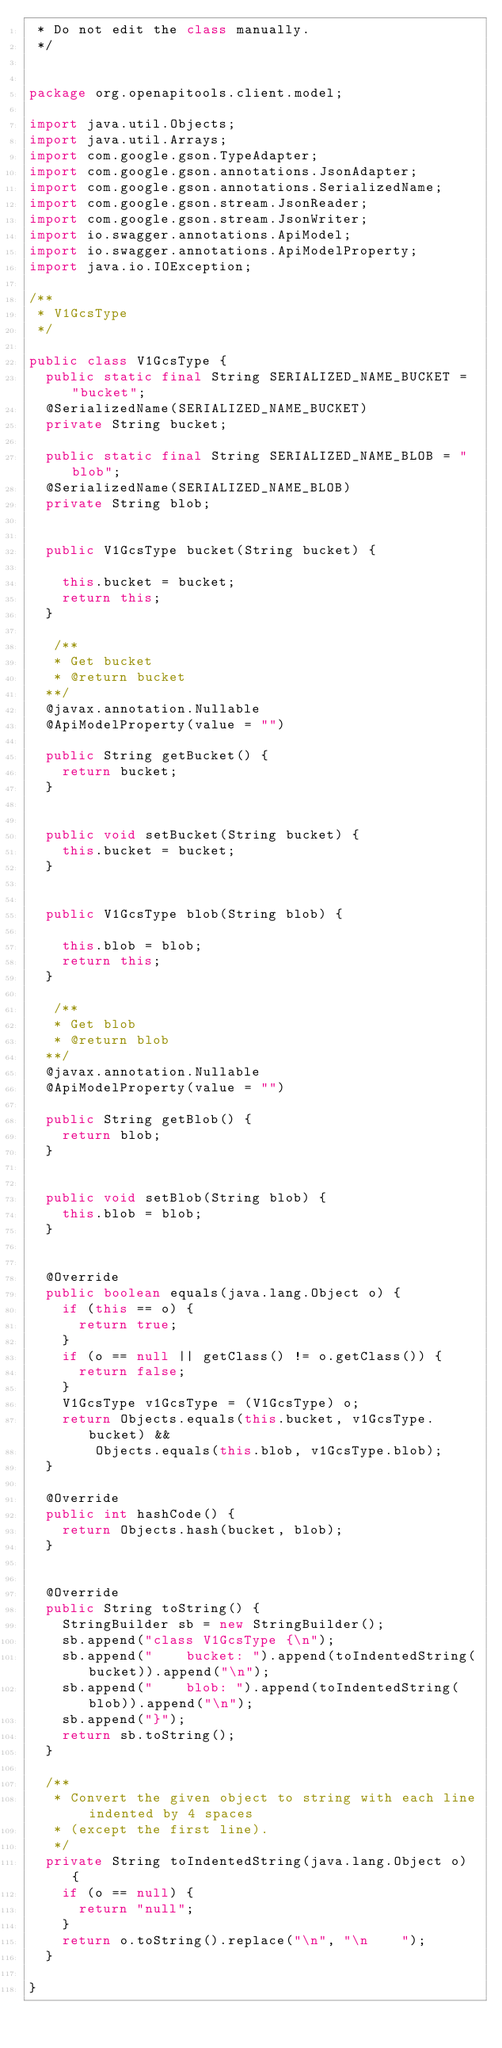Convert code to text. <code><loc_0><loc_0><loc_500><loc_500><_Java_> * Do not edit the class manually.
 */


package org.openapitools.client.model;

import java.util.Objects;
import java.util.Arrays;
import com.google.gson.TypeAdapter;
import com.google.gson.annotations.JsonAdapter;
import com.google.gson.annotations.SerializedName;
import com.google.gson.stream.JsonReader;
import com.google.gson.stream.JsonWriter;
import io.swagger.annotations.ApiModel;
import io.swagger.annotations.ApiModelProperty;
import java.io.IOException;

/**
 * V1GcsType
 */

public class V1GcsType {
  public static final String SERIALIZED_NAME_BUCKET = "bucket";
  @SerializedName(SERIALIZED_NAME_BUCKET)
  private String bucket;

  public static final String SERIALIZED_NAME_BLOB = "blob";
  @SerializedName(SERIALIZED_NAME_BLOB)
  private String blob;


  public V1GcsType bucket(String bucket) {
    
    this.bucket = bucket;
    return this;
  }

   /**
   * Get bucket
   * @return bucket
  **/
  @javax.annotation.Nullable
  @ApiModelProperty(value = "")

  public String getBucket() {
    return bucket;
  }


  public void setBucket(String bucket) {
    this.bucket = bucket;
  }


  public V1GcsType blob(String blob) {
    
    this.blob = blob;
    return this;
  }

   /**
   * Get blob
   * @return blob
  **/
  @javax.annotation.Nullable
  @ApiModelProperty(value = "")

  public String getBlob() {
    return blob;
  }


  public void setBlob(String blob) {
    this.blob = blob;
  }


  @Override
  public boolean equals(java.lang.Object o) {
    if (this == o) {
      return true;
    }
    if (o == null || getClass() != o.getClass()) {
      return false;
    }
    V1GcsType v1GcsType = (V1GcsType) o;
    return Objects.equals(this.bucket, v1GcsType.bucket) &&
        Objects.equals(this.blob, v1GcsType.blob);
  }

  @Override
  public int hashCode() {
    return Objects.hash(bucket, blob);
  }


  @Override
  public String toString() {
    StringBuilder sb = new StringBuilder();
    sb.append("class V1GcsType {\n");
    sb.append("    bucket: ").append(toIndentedString(bucket)).append("\n");
    sb.append("    blob: ").append(toIndentedString(blob)).append("\n");
    sb.append("}");
    return sb.toString();
  }

  /**
   * Convert the given object to string with each line indented by 4 spaces
   * (except the first line).
   */
  private String toIndentedString(java.lang.Object o) {
    if (o == null) {
      return "null";
    }
    return o.toString().replace("\n", "\n    ");
  }

}

</code> 